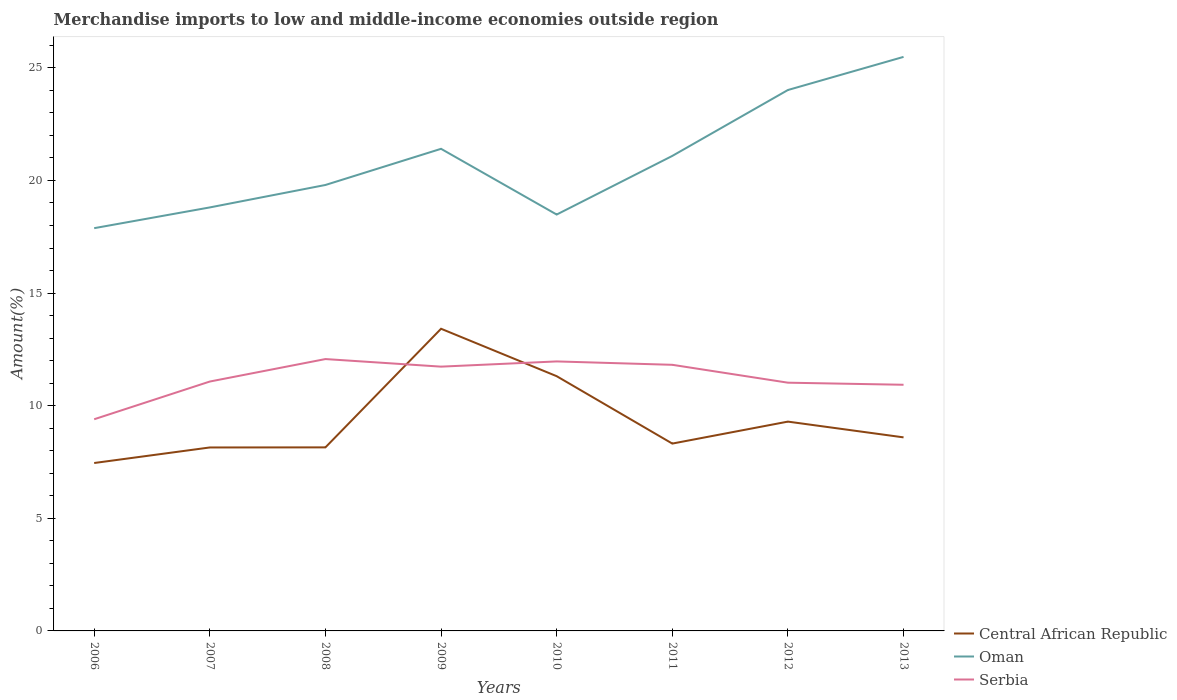Does the line corresponding to Central African Republic intersect with the line corresponding to Oman?
Offer a terse response. No. Across all years, what is the maximum percentage of amount earned from merchandise imports in Central African Republic?
Provide a short and direct response. 7.46. What is the total percentage of amount earned from merchandise imports in Oman in the graph?
Make the answer very short. -1.92. What is the difference between the highest and the second highest percentage of amount earned from merchandise imports in Serbia?
Your response must be concise. 2.67. What is the difference between the highest and the lowest percentage of amount earned from merchandise imports in Oman?
Offer a very short reply. 4. How many years are there in the graph?
Your answer should be compact. 8. How are the legend labels stacked?
Your answer should be very brief. Vertical. What is the title of the graph?
Your answer should be very brief. Merchandise imports to low and middle-income economies outside region. What is the label or title of the Y-axis?
Keep it short and to the point. Amount(%). What is the Amount(%) in Central African Republic in 2006?
Your answer should be very brief. 7.46. What is the Amount(%) in Oman in 2006?
Give a very brief answer. 17.88. What is the Amount(%) of Serbia in 2006?
Offer a very short reply. 9.4. What is the Amount(%) of Central African Republic in 2007?
Keep it short and to the point. 8.15. What is the Amount(%) in Oman in 2007?
Keep it short and to the point. 18.8. What is the Amount(%) of Serbia in 2007?
Your answer should be very brief. 11.07. What is the Amount(%) of Central African Republic in 2008?
Keep it short and to the point. 8.15. What is the Amount(%) in Oman in 2008?
Offer a terse response. 19.8. What is the Amount(%) of Serbia in 2008?
Ensure brevity in your answer.  12.07. What is the Amount(%) in Central African Republic in 2009?
Give a very brief answer. 13.42. What is the Amount(%) in Oman in 2009?
Make the answer very short. 21.41. What is the Amount(%) of Serbia in 2009?
Ensure brevity in your answer.  11.73. What is the Amount(%) in Central African Republic in 2010?
Offer a terse response. 11.31. What is the Amount(%) of Oman in 2010?
Ensure brevity in your answer.  18.49. What is the Amount(%) in Serbia in 2010?
Your answer should be very brief. 11.97. What is the Amount(%) in Central African Republic in 2011?
Ensure brevity in your answer.  8.32. What is the Amount(%) of Oman in 2011?
Your response must be concise. 21.09. What is the Amount(%) of Serbia in 2011?
Your answer should be very brief. 11.82. What is the Amount(%) of Central African Republic in 2012?
Offer a very short reply. 9.29. What is the Amount(%) in Oman in 2012?
Keep it short and to the point. 24.02. What is the Amount(%) in Serbia in 2012?
Give a very brief answer. 11.02. What is the Amount(%) in Central African Republic in 2013?
Provide a short and direct response. 8.59. What is the Amount(%) in Oman in 2013?
Keep it short and to the point. 25.49. What is the Amount(%) of Serbia in 2013?
Give a very brief answer. 10.93. Across all years, what is the maximum Amount(%) in Central African Republic?
Ensure brevity in your answer.  13.42. Across all years, what is the maximum Amount(%) in Oman?
Your response must be concise. 25.49. Across all years, what is the maximum Amount(%) in Serbia?
Your answer should be compact. 12.07. Across all years, what is the minimum Amount(%) of Central African Republic?
Provide a succinct answer. 7.46. Across all years, what is the minimum Amount(%) of Oman?
Give a very brief answer. 17.88. Across all years, what is the minimum Amount(%) in Serbia?
Make the answer very short. 9.4. What is the total Amount(%) of Central African Republic in the graph?
Provide a succinct answer. 74.68. What is the total Amount(%) of Oman in the graph?
Give a very brief answer. 166.97. What is the total Amount(%) in Serbia in the graph?
Your answer should be compact. 90.01. What is the difference between the Amount(%) of Central African Republic in 2006 and that in 2007?
Offer a terse response. -0.69. What is the difference between the Amount(%) of Oman in 2006 and that in 2007?
Provide a succinct answer. -0.92. What is the difference between the Amount(%) of Serbia in 2006 and that in 2007?
Provide a succinct answer. -1.67. What is the difference between the Amount(%) in Central African Republic in 2006 and that in 2008?
Your response must be concise. -0.69. What is the difference between the Amount(%) of Oman in 2006 and that in 2008?
Make the answer very short. -1.92. What is the difference between the Amount(%) in Serbia in 2006 and that in 2008?
Your answer should be very brief. -2.67. What is the difference between the Amount(%) of Central African Republic in 2006 and that in 2009?
Offer a very short reply. -5.96. What is the difference between the Amount(%) of Oman in 2006 and that in 2009?
Your answer should be very brief. -3.52. What is the difference between the Amount(%) in Serbia in 2006 and that in 2009?
Give a very brief answer. -2.34. What is the difference between the Amount(%) of Central African Republic in 2006 and that in 2010?
Provide a succinct answer. -3.85. What is the difference between the Amount(%) in Oman in 2006 and that in 2010?
Offer a terse response. -0.6. What is the difference between the Amount(%) in Serbia in 2006 and that in 2010?
Offer a very short reply. -2.57. What is the difference between the Amount(%) in Central African Republic in 2006 and that in 2011?
Make the answer very short. -0.86. What is the difference between the Amount(%) in Oman in 2006 and that in 2011?
Keep it short and to the point. -3.21. What is the difference between the Amount(%) of Serbia in 2006 and that in 2011?
Your answer should be very brief. -2.42. What is the difference between the Amount(%) in Central African Republic in 2006 and that in 2012?
Your response must be concise. -1.84. What is the difference between the Amount(%) of Oman in 2006 and that in 2012?
Ensure brevity in your answer.  -6.13. What is the difference between the Amount(%) in Serbia in 2006 and that in 2012?
Ensure brevity in your answer.  -1.62. What is the difference between the Amount(%) of Central African Republic in 2006 and that in 2013?
Give a very brief answer. -1.14. What is the difference between the Amount(%) in Oman in 2006 and that in 2013?
Offer a terse response. -7.61. What is the difference between the Amount(%) of Serbia in 2006 and that in 2013?
Your response must be concise. -1.53. What is the difference between the Amount(%) in Central African Republic in 2007 and that in 2008?
Make the answer very short. -0. What is the difference between the Amount(%) in Oman in 2007 and that in 2008?
Make the answer very short. -1. What is the difference between the Amount(%) of Serbia in 2007 and that in 2008?
Give a very brief answer. -1. What is the difference between the Amount(%) of Central African Republic in 2007 and that in 2009?
Offer a terse response. -5.27. What is the difference between the Amount(%) of Oman in 2007 and that in 2009?
Offer a terse response. -2.6. What is the difference between the Amount(%) of Serbia in 2007 and that in 2009?
Ensure brevity in your answer.  -0.66. What is the difference between the Amount(%) in Central African Republic in 2007 and that in 2010?
Keep it short and to the point. -3.16. What is the difference between the Amount(%) of Oman in 2007 and that in 2010?
Keep it short and to the point. 0.32. What is the difference between the Amount(%) of Serbia in 2007 and that in 2010?
Your answer should be very brief. -0.89. What is the difference between the Amount(%) of Central African Republic in 2007 and that in 2011?
Make the answer very short. -0.17. What is the difference between the Amount(%) of Oman in 2007 and that in 2011?
Provide a succinct answer. -2.29. What is the difference between the Amount(%) in Serbia in 2007 and that in 2011?
Offer a very short reply. -0.74. What is the difference between the Amount(%) of Central African Republic in 2007 and that in 2012?
Make the answer very short. -1.15. What is the difference between the Amount(%) in Oman in 2007 and that in 2012?
Ensure brevity in your answer.  -5.21. What is the difference between the Amount(%) in Serbia in 2007 and that in 2012?
Offer a very short reply. 0.05. What is the difference between the Amount(%) in Central African Republic in 2007 and that in 2013?
Your answer should be compact. -0.45. What is the difference between the Amount(%) of Oman in 2007 and that in 2013?
Keep it short and to the point. -6.68. What is the difference between the Amount(%) in Serbia in 2007 and that in 2013?
Provide a short and direct response. 0.14. What is the difference between the Amount(%) in Central African Republic in 2008 and that in 2009?
Provide a succinct answer. -5.27. What is the difference between the Amount(%) of Oman in 2008 and that in 2009?
Your answer should be compact. -1.61. What is the difference between the Amount(%) of Serbia in 2008 and that in 2009?
Give a very brief answer. 0.34. What is the difference between the Amount(%) of Central African Republic in 2008 and that in 2010?
Make the answer very short. -3.16. What is the difference between the Amount(%) in Oman in 2008 and that in 2010?
Keep it short and to the point. 1.31. What is the difference between the Amount(%) of Serbia in 2008 and that in 2010?
Keep it short and to the point. 0.11. What is the difference between the Amount(%) of Central African Republic in 2008 and that in 2011?
Your answer should be very brief. -0.17. What is the difference between the Amount(%) in Oman in 2008 and that in 2011?
Keep it short and to the point. -1.29. What is the difference between the Amount(%) of Serbia in 2008 and that in 2011?
Offer a terse response. 0.26. What is the difference between the Amount(%) in Central African Republic in 2008 and that in 2012?
Your answer should be compact. -1.14. What is the difference between the Amount(%) of Oman in 2008 and that in 2012?
Ensure brevity in your answer.  -4.22. What is the difference between the Amount(%) in Serbia in 2008 and that in 2012?
Make the answer very short. 1.05. What is the difference between the Amount(%) of Central African Republic in 2008 and that in 2013?
Make the answer very short. -0.44. What is the difference between the Amount(%) of Oman in 2008 and that in 2013?
Offer a very short reply. -5.69. What is the difference between the Amount(%) in Serbia in 2008 and that in 2013?
Make the answer very short. 1.14. What is the difference between the Amount(%) in Central African Republic in 2009 and that in 2010?
Give a very brief answer. 2.11. What is the difference between the Amount(%) of Oman in 2009 and that in 2010?
Offer a very short reply. 2.92. What is the difference between the Amount(%) in Serbia in 2009 and that in 2010?
Make the answer very short. -0.23. What is the difference between the Amount(%) of Central African Republic in 2009 and that in 2011?
Your answer should be compact. 5.1. What is the difference between the Amount(%) in Oman in 2009 and that in 2011?
Make the answer very short. 0.32. What is the difference between the Amount(%) in Serbia in 2009 and that in 2011?
Provide a short and direct response. -0.08. What is the difference between the Amount(%) in Central African Republic in 2009 and that in 2012?
Your answer should be compact. 4.12. What is the difference between the Amount(%) in Oman in 2009 and that in 2012?
Your answer should be very brief. -2.61. What is the difference between the Amount(%) in Serbia in 2009 and that in 2012?
Ensure brevity in your answer.  0.71. What is the difference between the Amount(%) in Central African Republic in 2009 and that in 2013?
Provide a succinct answer. 4.82. What is the difference between the Amount(%) of Oman in 2009 and that in 2013?
Your answer should be very brief. -4.08. What is the difference between the Amount(%) in Serbia in 2009 and that in 2013?
Your answer should be very brief. 0.81. What is the difference between the Amount(%) in Central African Republic in 2010 and that in 2011?
Give a very brief answer. 2.99. What is the difference between the Amount(%) in Oman in 2010 and that in 2011?
Offer a terse response. -2.6. What is the difference between the Amount(%) in Central African Republic in 2010 and that in 2012?
Give a very brief answer. 2.02. What is the difference between the Amount(%) of Oman in 2010 and that in 2012?
Give a very brief answer. -5.53. What is the difference between the Amount(%) in Serbia in 2010 and that in 2012?
Keep it short and to the point. 0.94. What is the difference between the Amount(%) of Central African Republic in 2010 and that in 2013?
Provide a short and direct response. 2.72. What is the difference between the Amount(%) of Oman in 2010 and that in 2013?
Provide a succinct answer. -7. What is the difference between the Amount(%) in Serbia in 2010 and that in 2013?
Ensure brevity in your answer.  1.04. What is the difference between the Amount(%) of Central African Republic in 2011 and that in 2012?
Offer a terse response. -0.98. What is the difference between the Amount(%) in Oman in 2011 and that in 2012?
Provide a short and direct response. -2.93. What is the difference between the Amount(%) of Serbia in 2011 and that in 2012?
Offer a terse response. 0.79. What is the difference between the Amount(%) in Central African Republic in 2011 and that in 2013?
Provide a succinct answer. -0.28. What is the difference between the Amount(%) of Oman in 2011 and that in 2013?
Give a very brief answer. -4.4. What is the difference between the Amount(%) of Serbia in 2011 and that in 2013?
Your answer should be very brief. 0.89. What is the difference between the Amount(%) of Central African Republic in 2012 and that in 2013?
Your answer should be compact. 0.7. What is the difference between the Amount(%) of Oman in 2012 and that in 2013?
Your answer should be compact. -1.47. What is the difference between the Amount(%) in Serbia in 2012 and that in 2013?
Make the answer very short. 0.09. What is the difference between the Amount(%) in Central African Republic in 2006 and the Amount(%) in Oman in 2007?
Your answer should be compact. -11.35. What is the difference between the Amount(%) in Central African Republic in 2006 and the Amount(%) in Serbia in 2007?
Make the answer very short. -3.62. What is the difference between the Amount(%) of Oman in 2006 and the Amount(%) of Serbia in 2007?
Ensure brevity in your answer.  6.81. What is the difference between the Amount(%) of Central African Republic in 2006 and the Amount(%) of Oman in 2008?
Ensure brevity in your answer.  -12.34. What is the difference between the Amount(%) in Central African Republic in 2006 and the Amount(%) in Serbia in 2008?
Keep it short and to the point. -4.62. What is the difference between the Amount(%) of Oman in 2006 and the Amount(%) of Serbia in 2008?
Make the answer very short. 5.81. What is the difference between the Amount(%) of Central African Republic in 2006 and the Amount(%) of Oman in 2009?
Keep it short and to the point. -13.95. What is the difference between the Amount(%) of Central African Republic in 2006 and the Amount(%) of Serbia in 2009?
Provide a succinct answer. -4.28. What is the difference between the Amount(%) in Oman in 2006 and the Amount(%) in Serbia in 2009?
Offer a very short reply. 6.15. What is the difference between the Amount(%) of Central African Republic in 2006 and the Amount(%) of Oman in 2010?
Provide a short and direct response. -11.03. What is the difference between the Amount(%) of Central African Republic in 2006 and the Amount(%) of Serbia in 2010?
Provide a short and direct response. -4.51. What is the difference between the Amount(%) in Oman in 2006 and the Amount(%) in Serbia in 2010?
Give a very brief answer. 5.92. What is the difference between the Amount(%) of Central African Republic in 2006 and the Amount(%) of Oman in 2011?
Provide a succinct answer. -13.63. What is the difference between the Amount(%) in Central African Republic in 2006 and the Amount(%) in Serbia in 2011?
Offer a terse response. -4.36. What is the difference between the Amount(%) of Oman in 2006 and the Amount(%) of Serbia in 2011?
Provide a short and direct response. 6.07. What is the difference between the Amount(%) of Central African Republic in 2006 and the Amount(%) of Oman in 2012?
Keep it short and to the point. -16.56. What is the difference between the Amount(%) of Central African Republic in 2006 and the Amount(%) of Serbia in 2012?
Make the answer very short. -3.57. What is the difference between the Amount(%) in Oman in 2006 and the Amount(%) in Serbia in 2012?
Make the answer very short. 6.86. What is the difference between the Amount(%) in Central African Republic in 2006 and the Amount(%) in Oman in 2013?
Give a very brief answer. -18.03. What is the difference between the Amount(%) in Central African Republic in 2006 and the Amount(%) in Serbia in 2013?
Give a very brief answer. -3.47. What is the difference between the Amount(%) of Oman in 2006 and the Amount(%) of Serbia in 2013?
Offer a very short reply. 6.95. What is the difference between the Amount(%) in Central African Republic in 2007 and the Amount(%) in Oman in 2008?
Provide a succinct answer. -11.65. What is the difference between the Amount(%) in Central African Republic in 2007 and the Amount(%) in Serbia in 2008?
Ensure brevity in your answer.  -3.93. What is the difference between the Amount(%) of Oman in 2007 and the Amount(%) of Serbia in 2008?
Keep it short and to the point. 6.73. What is the difference between the Amount(%) of Central African Republic in 2007 and the Amount(%) of Oman in 2009?
Keep it short and to the point. -13.26. What is the difference between the Amount(%) in Central African Republic in 2007 and the Amount(%) in Serbia in 2009?
Offer a terse response. -3.59. What is the difference between the Amount(%) in Oman in 2007 and the Amount(%) in Serbia in 2009?
Keep it short and to the point. 7.07. What is the difference between the Amount(%) in Central African Republic in 2007 and the Amount(%) in Oman in 2010?
Your response must be concise. -10.34. What is the difference between the Amount(%) of Central African Republic in 2007 and the Amount(%) of Serbia in 2010?
Your answer should be compact. -3.82. What is the difference between the Amount(%) in Oman in 2007 and the Amount(%) in Serbia in 2010?
Ensure brevity in your answer.  6.84. What is the difference between the Amount(%) in Central African Republic in 2007 and the Amount(%) in Oman in 2011?
Ensure brevity in your answer.  -12.94. What is the difference between the Amount(%) in Central African Republic in 2007 and the Amount(%) in Serbia in 2011?
Your answer should be very brief. -3.67. What is the difference between the Amount(%) of Oman in 2007 and the Amount(%) of Serbia in 2011?
Provide a short and direct response. 6.99. What is the difference between the Amount(%) in Central African Republic in 2007 and the Amount(%) in Oman in 2012?
Give a very brief answer. -15.87. What is the difference between the Amount(%) of Central African Republic in 2007 and the Amount(%) of Serbia in 2012?
Your answer should be very brief. -2.88. What is the difference between the Amount(%) of Oman in 2007 and the Amount(%) of Serbia in 2012?
Offer a very short reply. 7.78. What is the difference between the Amount(%) of Central African Republic in 2007 and the Amount(%) of Oman in 2013?
Your answer should be compact. -17.34. What is the difference between the Amount(%) in Central African Republic in 2007 and the Amount(%) in Serbia in 2013?
Provide a short and direct response. -2.78. What is the difference between the Amount(%) in Oman in 2007 and the Amount(%) in Serbia in 2013?
Provide a succinct answer. 7.87. What is the difference between the Amount(%) of Central African Republic in 2008 and the Amount(%) of Oman in 2009?
Your answer should be compact. -13.26. What is the difference between the Amount(%) in Central African Republic in 2008 and the Amount(%) in Serbia in 2009?
Your answer should be compact. -3.58. What is the difference between the Amount(%) in Oman in 2008 and the Amount(%) in Serbia in 2009?
Offer a terse response. 8.07. What is the difference between the Amount(%) in Central African Republic in 2008 and the Amount(%) in Oman in 2010?
Your answer should be very brief. -10.34. What is the difference between the Amount(%) of Central African Republic in 2008 and the Amount(%) of Serbia in 2010?
Provide a succinct answer. -3.82. What is the difference between the Amount(%) in Oman in 2008 and the Amount(%) in Serbia in 2010?
Make the answer very short. 7.83. What is the difference between the Amount(%) of Central African Republic in 2008 and the Amount(%) of Oman in 2011?
Offer a very short reply. -12.94. What is the difference between the Amount(%) of Central African Republic in 2008 and the Amount(%) of Serbia in 2011?
Offer a terse response. -3.67. What is the difference between the Amount(%) in Oman in 2008 and the Amount(%) in Serbia in 2011?
Offer a very short reply. 7.98. What is the difference between the Amount(%) in Central African Republic in 2008 and the Amount(%) in Oman in 2012?
Your answer should be compact. -15.87. What is the difference between the Amount(%) in Central African Republic in 2008 and the Amount(%) in Serbia in 2012?
Provide a succinct answer. -2.87. What is the difference between the Amount(%) of Oman in 2008 and the Amount(%) of Serbia in 2012?
Offer a terse response. 8.78. What is the difference between the Amount(%) of Central African Republic in 2008 and the Amount(%) of Oman in 2013?
Make the answer very short. -17.34. What is the difference between the Amount(%) of Central African Republic in 2008 and the Amount(%) of Serbia in 2013?
Provide a short and direct response. -2.78. What is the difference between the Amount(%) in Oman in 2008 and the Amount(%) in Serbia in 2013?
Make the answer very short. 8.87. What is the difference between the Amount(%) in Central African Republic in 2009 and the Amount(%) in Oman in 2010?
Your answer should be compact. -5.07. What is the difference between the Amount(%) of Central African Republic in 2009 and the Amount(%) of Serbia in 2010?
Offer a terse response. 1.45. What is the difference between the Amount(%) in Oman in 2009 and the Amount(%) in Serbia in 2010?
Ensure brevity in your answer.  9.44. What is the difference between the Amount(%) of Central African Republic in 2009 and the Amount(%) of Oman in 2011?
Give a very brief answer. -7.67. What is the difference between the Amount(%) of Central African Republic in 2009 and the Amount(%) of Serbia in 2011?
Your response must be concise. 1.6. What is the difference between the Amount(%) in Oman in 2009 and the Amount(%) in Serbia in 2011?
Provide a succinct answer. 9.59. What is the difference between the Amount(%) in Central African Republic in 2009 and the Amount(%) in Oman in 2012?
Your answer should be compact. -10.6. What is the difference between the Amount(%) in Central African Republic in 2009 and the Amount(%) in Serbia in 2012?
Your answer should be compact. 2.39. What is the difference between the Amount(%) in Oman in 2009 and the Amount(%) in Serbia in 2012?
Offer a very short reply. 10.38. What is the difference between the Amount(%) in Central African Republic in 2009 and the Amount(%) in Oman in 2013?
Your answer should be very brief. -12.07. What is the difference between the Amount(%) in Central African Republic in 2009 and the Amount(%) in Serbia in 2013?
Offer a very short reply. 2.49. What is the difference between the Amount(%) of Oman in 2009 and the Amount(%) of Serbia in 2013?
Offer a terse response. 10.48. What is the difference between the Amount(%) of Central African Republic in 2010 and the Amount(%) of Oman in 2011?
Your answer should be very brief. -9.78. What is the difference between the Amount(%) in Central African Republic in 2010 and the Amount(%) in Serbia in 2011?
Your response must be concise. -0.51. What is the difference between the Amount(%) of Oman in 2010 and the Amount(%) of Serbia in 2011?
Provide a succinct answer. 6.67. What is the difference between the Amount(%) in Central African Republic in 2010 and the Amount(%) in Oman in 2012?
Give a very brief answer. -12.71. What is the difference between the Amount(%) of Central African Republic in 2010 and the Amount(%) of Serbia in 2012?
Provide a short and direct response. 0.29. What is the difference between the Amount(%) of Oman in 2010 and the Amount(%) of Serbia in 2012?
Give a very brief answer. 7.47. What is the difference between the Amount(%) in Central African Republic in 2010 and the Amount(%) in Oman in 2013?
Your answer should be very brief. -14.18. What is the difference between the Amount(%) in Central African Republic in 2010 and the Amount(%) in Serbia in 2013?
Make the answer very short. 0.38. What is the difference between the Amount(%) in Oman in 2010 and the Amount(%) in Serbia in 2013?
Provide a succinct answer. 7.56. What is the difference between the Amount(%) in Central African Republic in 2011 and the Amount(%) in Oman in 2012?
Provide a short and direct response. -15.7. What is the difference between the Amount(%) in Central African Republic in 2011 and the Amount(%) in Serbia in 2012?
Your answer should be compact. -2.7. What is the difference between the Amount(%) in Oman in 2011 and the Amount(%) in Serbia in 2012?
Your answer should be very brief. 10.07. What is the difference between the Amount(%) of Central African Republic in 2011 and the Amount(%) of Oman in 2013?
Ensure brevity in your answer.  -17.17. What is the difference between the Amount(%) of Central African Republic in 2011 and the Amount(%) of Serbia in 2013?
Your answer should be compact. -2.61. What is the difference between the Amount(%) of Oman in 2011 and the Amount(%) of Serbia in 2013?
Ensure brevity in your answer.  10.16. What is the difference between the Amount(%) of Central African Republic in 2012 and the Amount(%) of Oman in 2013?
Offer a terse response. -16.19. What is the difference between the Amount(%) in Central African Republic in 2012 and the Amount(%) in Serbia in 2013?
Make the answer very short. -1.64. What is the difference between the Amount(%) of Oman in 2012 and the Amount(%) of Serbia in 2013?
Give a very brief answer. 13.09. What is the average Amount(%) of Central African Republic per year?
Provide a short and direct response. 9.34. What is the average Amount(%) in Oman per year?
Your response must be concise. 20.87. What is the average Amount(%) in Serbia per year?
Make the answer very short. 11.25. In the year 2006, what is the difference between the Amount(%) in Central African Republic and Amount(%) in Oman?
Provide a succinct answer. -10.43. In the year 2006, what is the difference between the Amount(%) in Central African Republic and Amount(%) in Serbia?
Keep it short and to the point. -1.94. In the year 2006, what is the difference between the Amount(%) of Oman and Amount(%) of Serbia?
Provide a short and direct response. 8.48. In the year 2007, what is the difference between the Amount(%) in Central African Republic and Amount(%) in Oman?
Ensure brevity in your answer.  -10.66. In the year 2007, what is the difference between the Amount(%) in Central African Republic and Amount(%) in Serbia?
Provide a short and direct response. -2.93. In the year 2007, what is the difference between the Amount(%) of Oman and Amount(%) of Serbia?
Give a very brief answer. 7.73. In the year 2008, what is the difference between the Amount(%) of Central African Republic and Amount(%) of Oman?
Offer a very short reply. -11.65. In the year 2008, what is the difference between the Amount(%) in Central African Republic and Amount(%) in Serbia?
Your answer should be compact. -3.92. In the year 2008, what is the difference between the Amount(%) of Oman and Amount(%) of Serbia?
Your answer should be compact. 7.73. In the year 2009, what is the difference between the Amount(%) in Central African Republic and Amount(%) in Oman?
Give a very brief answer. -7.99. In the year 2009, what is the difference between the Amount(%) in Central African Republic and Amount(%) in Serbia?
Your answer should be compact. 1.68. In the year 2009, what is the difference between the Amount(%) in Oman and Amount(%) in Serbia?
Your answer should be compact. 9.67. In the year 2010, what is the difference between the Amount(%) of Central African Republic and Amount(%) of Oman?
Ensure brevity in your answer.  -7.18. In the year 2010, what is the difference between the Amount(%) in Central African Republic and Amount(%) in Serbia?
Offer a very short reply. -0.66. In the year 2010, what is the difference between the Amount(%) of Oman and Amount(%) of Serbia?
Give a very brief answer. 6.52. In the year 2011, what is the difference between the Amount(%) of Central African Republic and Amount(%) of Oman?
Give a very brief answer. -12.77. In the year 2011, what is the difference between the Amount(%) of Central African Republic and Amount(%) of Serbia?
Keep it short and to the point. -3.5. In the year 2011, what is the difference between the Amount(%) in Oman and Amount(%) in Serbia?
Your response must be concise. 9.27. In the year 2012, what is the difference between the Amount(%) in Central African Republic and Amount(%) in Oman?
Your answer should be compact. -14.72. In the year 2012, what is the difference between the Amount(%) of Central African Republic and Amount(%) of Serbia?
Your answer should be very brief. -1.73. In the year 2012, what is the difference between the Amount(%) of Oman and Amount(%) of Serbia?
Provide a succinct answer. 13. In the year 2013, what is the difference between the Amount(%) of Central African Republic and Amount(%) of Oman?
Ensure brevity in your answer.  -16.89. In the year 2013, what is the difference between the Amount(%) in Central African Republic and Amount(%) in Serbia?
Your answer should be compact. -2.34. In the year 2013, what is the difference between the Amount(%) of Oman and Amount(%) of Serbia?
Keep it short and to the point. 14.56. What is the ratio of the Amount(%) in Central African Republic in 2006 to that in 2007?
Make the answer very short. 0.92. What is the ratio of the Amount(%) in Oman in 2006 to that in 2007?
Your response must be concise. 0.95. What is the ratio of the Amount(%) of Serbia in 2006 to that in 2007?
Your answer should be compact. 0.85. What is the ratio of the Amount(%) in Central African Republic in 2006 to that in 2008?
Offer a very short reply. 0.91. What is the ratio of the Amount(%) of Oman in 2006 to that in 2008?
Give a very brief answer. 0.9. What is the ratio of the Amount(%) in Serbia in 2006 to that in 2008?
Provide a short and direct response. 0.78. What is the ratio of the Amount(%) of Central African Republic in 2006 to that in 2009?
Your answer should be very brief. 0.56. What is the ratio of the Amount(%) in Oman in 2006 to that in 2009?
Your response must be concise. 0.84. What is the ratio of the Amount(%) in Serbia in 2006 to that in 2009?
Your answer should be very brief. 0.8. What is the ratio of the Amount(%) in Central African Republic in 2006 to that in 2010?
Give a very brief answer. 0.66. What is the ratio of the Amount(%) in Oman in 2006 to that in 2010?
Your answer should be very brief. 0.97. What is the ratio of the Amount(%) in Serbia in 2006 to that in 2010?
Keep it short and to the point. 0.79. What is the ratio of the Amount(%) of Central African Republic in 2006 to that in 2011?
Provide a short and direct response. 0.9. What is the ratio of the Amount(%) of Oman in 2006 to that in 2011?
Provide a succinct answer. 0.85. What is the ratio of the Amount(%) of Serbia in 2006 to that in 2011?
Ensure brevity in your answer.  0.8. What is the ratio of the Amount(%) of Central African Republic in 2006 to that in 2012?
Offer a terse response. 0.8. What is the ratio of the Amount(%) of Oman in 2006 to that in 2012?
Provide a short and direct response. 0.74. What is the ratio of the Amount(%) of Serbia in 2006 to that in 2012?
Offer a terse response. 0.85. What is the ratio of the Amount(%) in Central African Republic in 2006 to that in 2013?
Your answer should be compact. 0.87. What is the ratio of the Amount(%) in Oman in 2006 to that in 2013?
Ensure brevity in your answer.  0.7. What is the ratio of the Amount(%) of Serbia in 2006 to that in 2013?
Ensure brevity in your answer.  0.86. What is the ratio of the Amount(%) in Central African Republic in 2007 to that in 2008?
Give a very brief answer. 1. What is the ratio of the Amount(%) of Oman in 2007 to that in 2008?
Your answer should be compact. 0.95. What is the ratio of the Amount(%) in Serbia in 2007 to that in 2008?
Your answer should be compact. 0.92. What is the ratio of the Amount(%) in Central African Republic in 2007 to that in 2009?
Ensure brevity in your answer.  0.61. What is the ratio of the Amount(%) of Oman in 2007 to that in 2009?
Your response must be concise. 0.88. What is the ratio of the Amount(%) in Serbia in 2007 to that in 2009?
Keep it short and to the point. 0.94. What is the ratio of the Amount(%) of Central African Republic in 2007 to that in 2010?
Your answer should be very brief. 0.72. What is the ratio of the Amount(%) in Oman in 2007 to that in 2010?
Offer a very short reply. 1.02. What is the ratio of the Amount(%) in Serbia in 2007 to that in 2010?
Make the answer very short. 0.93. What is the ratio of the Amount(%) in Central African Republic in 2007 to that in 2011?
Your answer should be very brief. 0.98. What is the ratio of the Amount(%) in Oman in 2007 to that in 2011?
Your answer should be compact. 0.89. What is the ratio of the Amount(%) of Serbia in 2007 to that in 2011?
Make the answer very short. 0.94. What is the ratio of the Amount(%) in Central African Republic in 2007 to that in 2012?
Give a very brief answer. 0.88. What is the ratio of the Amount(%) of Oman in 2007 to that in 2012?
Your response must be concise. 0.78. What is the ratio of the Amount(%) in Serbia in 2007 to that in 2012?
Your answer should be very brief. 1. What is the ratio of the Amount(%) in Central African Republic in 2007 to that in 2013?
Make the answer very short. 0.95. What is the ratio of the Amount(%) in Oman in 2007 to that in 2013?
Offer a very short reply. 0.74. What is the ratio of the Amount(%) in Serbia in 2007 to that in 2013?
Keep it short and to the point. 1.01. What is the ratio of the Amount(%) of Central African Republic in 2008 to that in 2009?
Your answer should be very brief. 0.61. What is the ratio of the Amount(%) in Oman in 2008 to that in 2009?
Your answer should be compact. 0.93. What is the ratio of the Amount(%) of Serbia in 2008 to that in 2009?
Your answer should be compact. 1.03. What is the ratio of the Amount(%) of Central African Republic in 2008 to that in 2010?
Offer a very short reply. 0.72. What is the ratio of the Amount(%) of Oman in 2008 to that in 2010?
Your response must be concise. 1.07. What is the ratio of the Amount(%) of Serbia in 2008 to that in 2010?
Provide a short and direct response. 1.01. What is the ratio of the Amount(%) of Central African Republic in 2008 to that in 2011?
Your response must be concise. 0.98. What is the ratio of the Amount(%) in Oman in 2008 to that in 2011?
Ensure brevity in your answer.  0.94. What is the ratio of the Amount(%) of Serbia in 2008 to that in 2011?
Ensure brevity in your answer.  1.02. What is the ratio of the Amount(%) in Central African Republic in 2008 to that in 2012?
Keep it short and to the point. 0.88. What is the ratio of the Amount(%) in Oman in 2008 to that in 2012?
Provide a short and direct response. 0.82. What is the ratio of the Amount(%) of Serbia in 2008 to that in 2012?
Your response must be concise. 1.1. What is the ratio of the Amount(%) of Central African Republic in 2008 to that in 2013?
Offer a very short reply. 0.95. What is the ratio of the Amount(%) of Oman in 2008 to that in 2013?
Your response must be concise. 0.78. What is the ratio of the Amount(%) of Serbia in 2008 to that in 2013?
Your response must be concise. 1.1. What is the ratio of the Amount(%) in Central African Republic in 2009 to that in 2010?
Your response must be concise. 1.19. What is the ratio of the Amount(%) of Oman in 2009 to that in 2010?
Your response must be concise. 1.16. What is the ratio of the Amount(%) in Serbia in 2009 to that in 2010?
Make the answer very short. 0.98. What is the ratio of the Amount(%) of Central African Republic in 2009 to that in 2011?
Offer a very short reply. 1.61. What is the ratio of the Amount(%) in Oman in 2009 to that in 2011?
Offer a very short reply. 1.01. What is the ratio of the Amount(%) in Serbia in 2009 to that in 2011?
Offer a terse response. 0.99. What is the ratio of the Amount(%) in Central African Republic in 2009 to that in 2012?
Offer a terse response. 1.44. What is the ratio of the Amount(%) in Oman in 2009 to that in 2012?
Give a very brief answer. 0.89. What is the ratio of the Amount(%) of Serbia in 2009 to that in 2012?
Give a very brief answer. 1.06. What is the ratio of the Amount(%) of Central African Republic in 2009 to that in 2013?
Offer a terse response. 1.56. What is the ratio of the Amount(%) of Oman in 2009 to that in 2013?
Make the answer very short. 0.84. What is the ratio of the Amount(%) of Serbia in 2009 to that in 2013?
Your response must be concise. 1.07. What is the ratio of the Amount(%) of Central African Republic in 2010 to that in 2011?
Ensure brevity in your answer.  1.36. What is the ratio of the Amount(%) of Oman in 2010 to that in 2011?
Your response must be concise. 0.88. What is the ratio of the Amount(%) of Serbia in 2010 to that in 2011?
Give a very brief answer. 1.01. What is the ratio of the Amount(%) of Central African Republic in 2010 to that in 2012?
Give a very brief answer. 1.22. What is the ratio of the Amount(%) in Oman in 2010 to that in 2012?
Offer a very short reply. 0.77. What is the ratio of the Amount(%) in Serbia in 2010 to that in 2012?
Offer a very short reply. 1.09. What is the ratio of the Amount(%) in Central African Republic in 2010 to that in 2013?
Provide a short and direct response. 1.32. What is the ratio of the Amount(%) in Oman in 2010 to that in 2013?
Keep it short and to the point. 0.73. What is the ratio of the Amount(%) in Serbia in 2010 to that in 2013?
Ensure brevity in your answer.  1.09. What is the ratio of the Amount(%) in Central African Republic in 2011 to that in 2012?
Provide a short and direct response. 0.9. What is the ratio of the Amount(%) in Oman in 2011 to that in 2012?
Give a very brief answer. 0.88. What is the ratio of the Amount(%) of Serbia in 2011 to that in 2012?
Your answer should be compact. 1.07. What is the ratio of the Amount(%) in Central African Republic in 2011 to that in 2013?
Offer a very short reply. 0.97. What is the ratio of the Amount(%) in Oman in 2011 to that in 2013?
Offer a terse response. 0.83. What is the ratio of the Amount(%) of Serbia in 2011 to that in 2013?
Your answer should be compact. 1.08. What is the ratio of the Amount(%) in Central African Republic in 2012 to that in 2013?
Give a very brief answer. 1.08. What is the ratio of the Amount(%) in Oman in 2012 to that in 2013?
Your response must be concise. 0.94. What is the ratio of the Amount(%) of Serbia in 2012 to that in 2013?
Offer a terse response. 1.01. What is the difference between the highest and the second highest Amount(%) of Central African Republic?
Keep it short and to the point. 2.11. What is the difference between the highest and the second highest Amount(%) in Oman?
Give a very brief answer. 1.47. What is the difference between the highest and the second highest Amount(%) of Serbia?
Provide a succinct answer. 0.11. What is the difference between the highest and the lowest Amount(%) of Central African Republic?
Provide a succinct answer. 5.96. What is the difference between the highest and the lowest Amount(%) of Oman?
Provide a short and direct response. 7.61. What is the difference between the highest and the lowest Amount(%) in Serbia?
Provide a succinct answer. 2.67. 